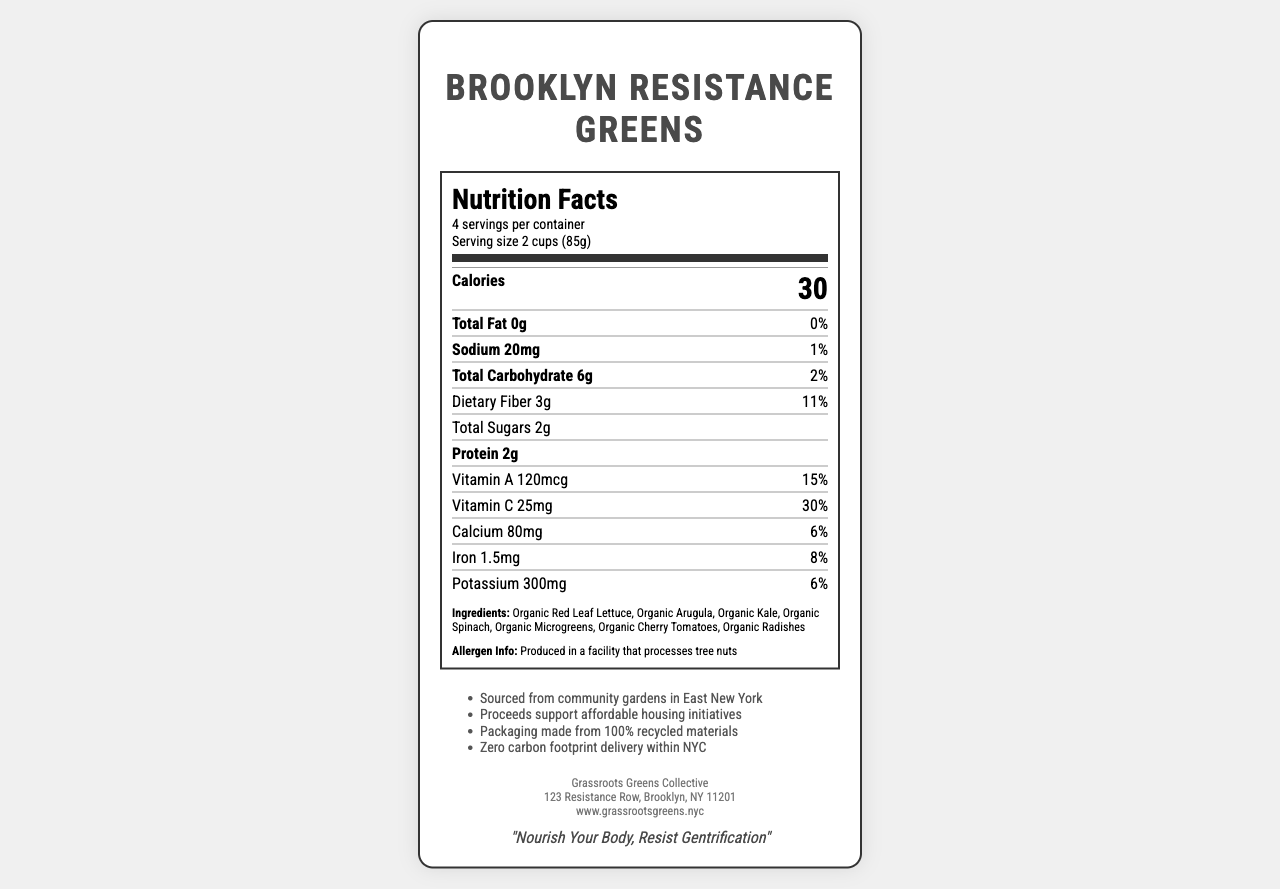what is the serving size of Brooklyn Resistance Greens? The serving size is clearly stated as "2 cups (85g)" in the document.
Answer: 2 cups (85g) how many servings are in one container? The document mentions "4 servings per container" in the serving information section.
Answer: 4 how many calories are in one serving? The document lists "Calories 30" in the nutrition facts section.
Answer: 30 what percent of daily value (DV) of dietary fiber does one serving provide? The nutritional information states that one serving provides "Dietary Fiber 3g" which is 11% of the daily value.
Answer: 11% how much iron is present in one serving? The amount of iron is listed as "1.5mg" in the nutrition facts section.
Answer: 1.5mg what vitamins and minerals are listed on the Nutrition Facts Label? The nutrition facts label lists Vitamin A, Vitamin C, Calcium, Iron, and Potassium.
Answer: Vitamin A, Vitamin C, Calcium, Iron, Potassium what allergens may be present according to the document? The allergen information states "Produced in a facility that processes tree nuts".
Answer: Tree nuts where are the ingredients sourced from? The additional information section states that the ingredients are "Sourced from community gardens in East New York".
Answer: Community gardens in East New York which company produces Brooklyn Resistance Greens? A. Urban Greens Co-op B. Grassroots Greens Collective C. Healthy Harvest LLC D. Fresh City Farms The company information section lists "Grassroots Greens Collective" as the producer.
Answer: B. Grassroots Greens Collective how much protein is in one serving? A. 0g B. 1g C. 2g D. 3g The nutritional information states that there are "2g" of protein in one serving.
Answer: C. 2g is this product locally-sourced from New York City? The additional information mentions that the ingredients are "Sourced from community gardens in East New York", indicating it is locally sourced.
Answer: Yes does the packaging of the product consist of any recycled materials? The additional information states "Packaging made from 100% recycled materials".
Answer: Yes summarize the main idea of the Nutrition Facts Label for Brooklyn Resistance Greens. The document provides nutritional information, ingredients, allergen info, sourcing details, and emphasizes sustainable practices and community support.
Answer: Brooklyn Resistance Greens is a locally-sourced, organic salad mix produced by Grassroots Greens Collective. It is rich in dietary fiber, Vitamin A, and Vitamin C, has low calories, and is produced in a facility that processes tree nuts. The ingredients are sourced from community gardens in East New York, and proceeds support affordable housing initiatives. Packaging is made from recycled materials, and delivery is zero carbon footprint within NYC. where can I buy Brooklyn Resistance Greens in Brooklyn? The document does not provide any information about specific locations or stores where the product can be bought in Brooklyn.
Answer: Cannot be determined 